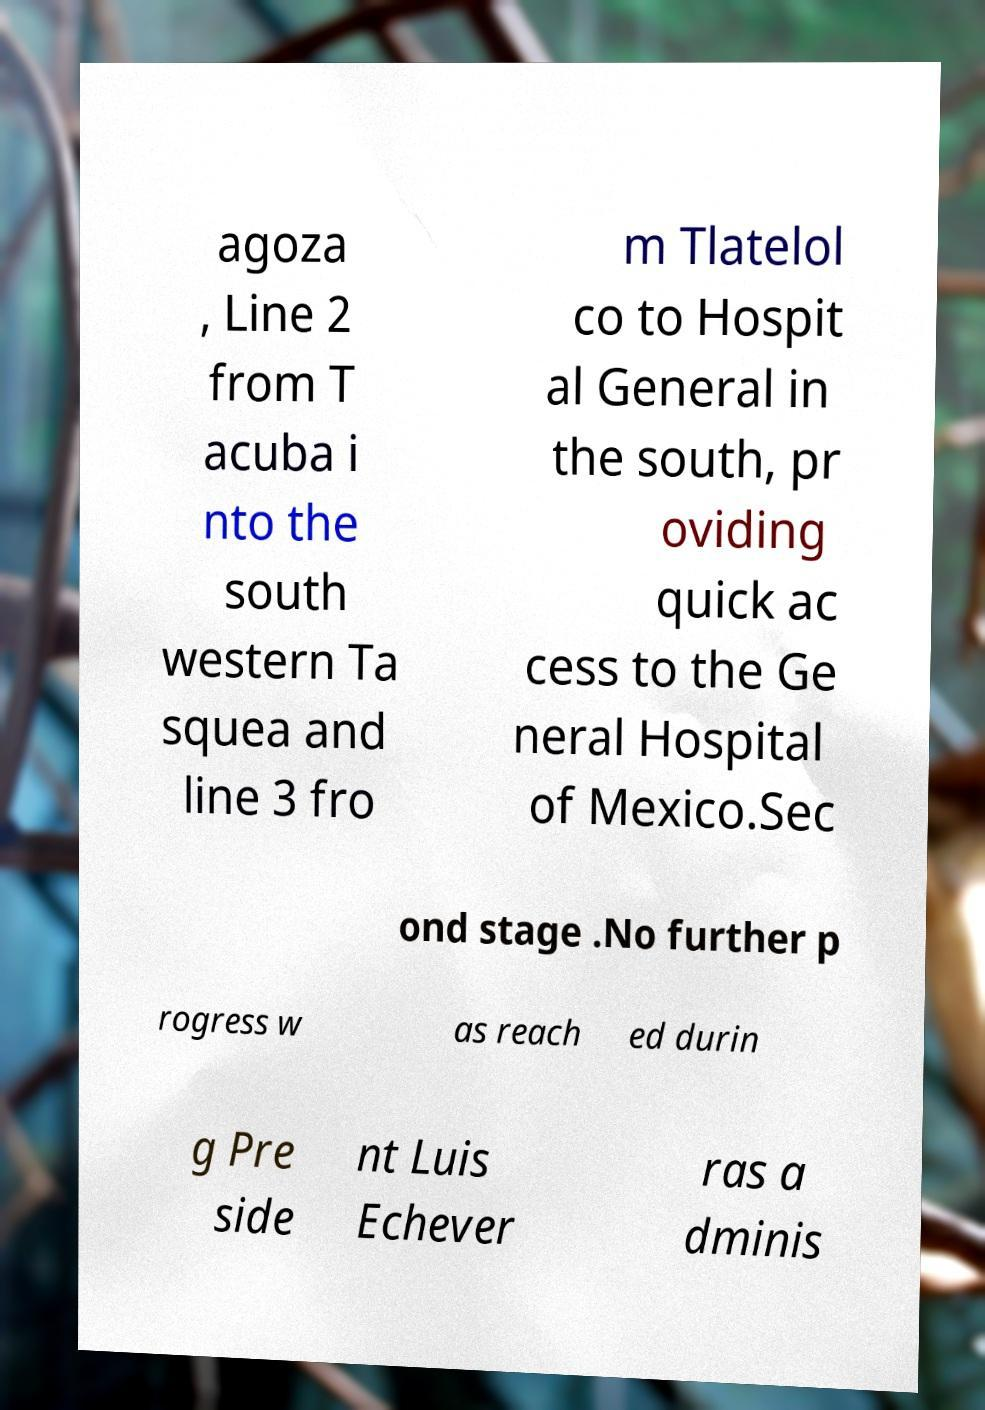Can you accurately transcribe the text from the provided image for me? agoza , Line 2 from T acuba i nto the south western Ta squea and line 3 fro m Tlatelol co to Hospit al General in the south, pr oviding quick ac cess to the Ge neral Hospital of Mexico.Sec ond stage .No further p rogress w as reach ed durin g Pre side nt Luis Echever ras a dminis 